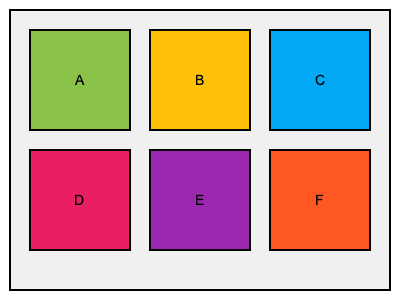Which of the packaging materials represented by the colored boxes are most likely to be eco-friendly and suitable for vegan snacks at an environmental rally? To determine which packaging materials are most eco-friendly and suitable for vegan snacks at an environmental rally, we need to consider the following factors:

1. Color association: In sustainable packaging, green is often associated with eco-friendliness.
2. Natural materials: Earth tones might represent biodegradable or compostable materials.
3. Recyclability: Blue is commonly used to represent recyclable materials.

Analyzing the options:

A (Green): The green color strongly suggests an eco-friendly material, possibly made from plant-based sources or biodegradable materials.

B (Yellow): Yellow could represent a natural material like unbleached paper or bamboo, which are biodegradable options.

C (Blue): Blue often signifies recyclable materials, which are considered eco-friendly.

D (Pink), E (Purple), and F (Orange): These bright, artificial colors are less likely to represent eco-friendly materials and more likely to be associated with conventional plastics or synthetic materials.

Given the context of vegan snacks at an environmental rally, the most suitable options would be those that are both eco-friendly and align with vegan principles. Therefore, the best choices are likely to be A (Green) and B (Yellow), as they represent materials that are probably plant-based, biodegradable, or compostable. C (Blue) is also a good option as it likely represents recyclable materials.
Answer: A, B, and C 